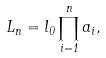Convert formula to latex. <formula><loc_0><loc_0><loc_500><loc_500>L _ { n } = { l _ { 0 } } \prod _ { i = 1 } ^ { n } a _ { i } ,</formula> 